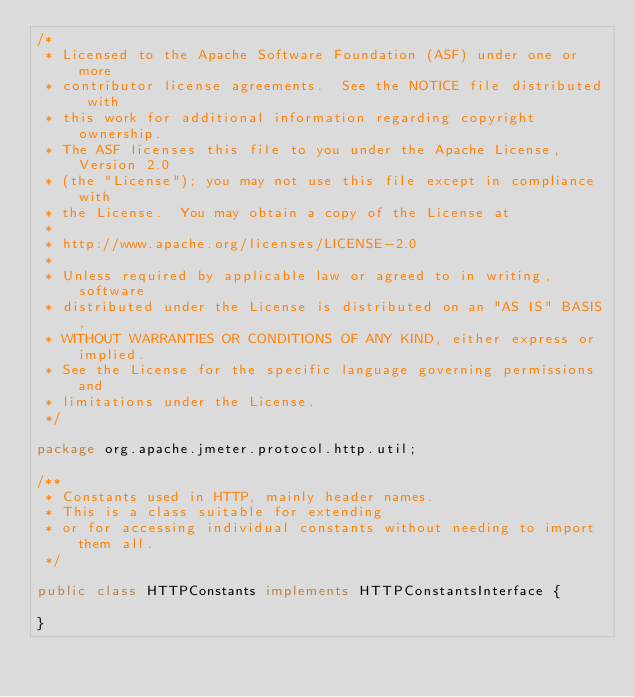<code> <loc_0><loc_0><loc_500><loc_500><_Java_>/*
 * Licensed to the Apache Software Foundation (ASF) under one or more
 * contributor license agreements.  See the NOTICE file distributed with
 * this work for additional information regarding copyright ownership.
 * The ASF licenses this file to you under the Apache License, Version 2.0
 * (the "License"); you may not use this file except in compliance with
 * the License.  You may obtain a copy of the License at
 *
 * http://www.apache.org/licenses/LICENSE-2.0
 *
 * Unless required by applicable law or agreed to in writing, software
 * distributed under the License is distributed on an "AS IS" BASIS,
 * WITHOUT WARRANTIES OR CONDITIONS OF ANY KIND, either express or implied.
 * See the License for the specific language governing permissions and
 * limitations under the License.
 */

package org.apache.jmeter.protocol.http.util;

/**
 * Constants used in HTTP, mainly header names.
 * This is a class suitable for extending
 * or for accessing individual constants without needing to import them all.
 */

public class HTTPConstants implements HTTPConstantsInterface {

}
</code> 